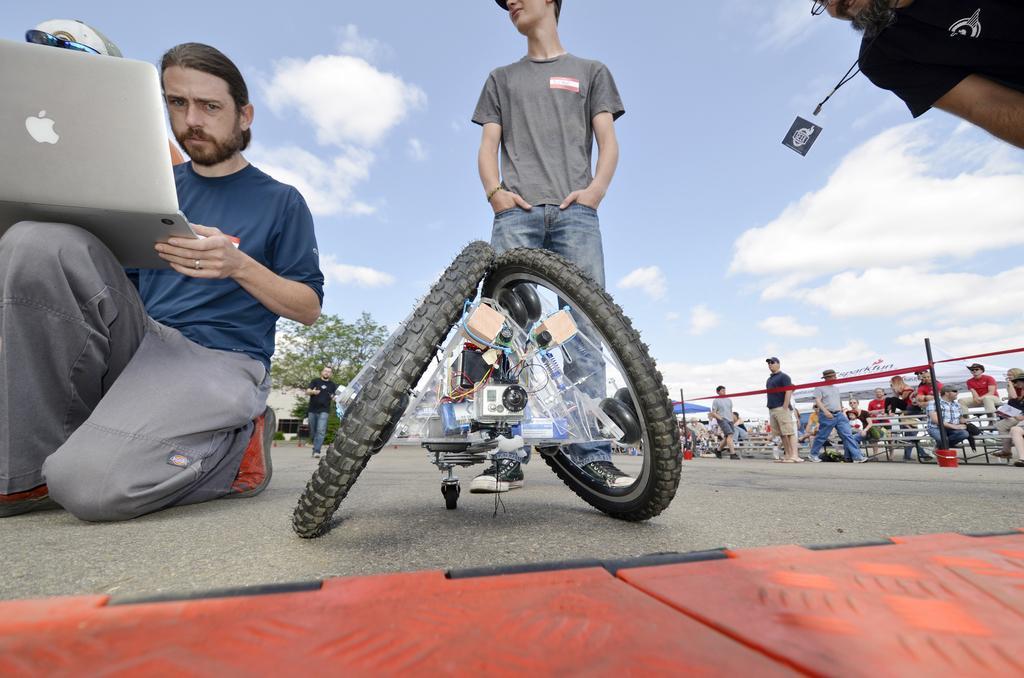Can you describe this image briefly? In the front of the image I can see people, wheels and device. Among them one person is holding a laptop. In the background of the image there are people, benches, rods, cloudy sky, tree, tents and objects. 